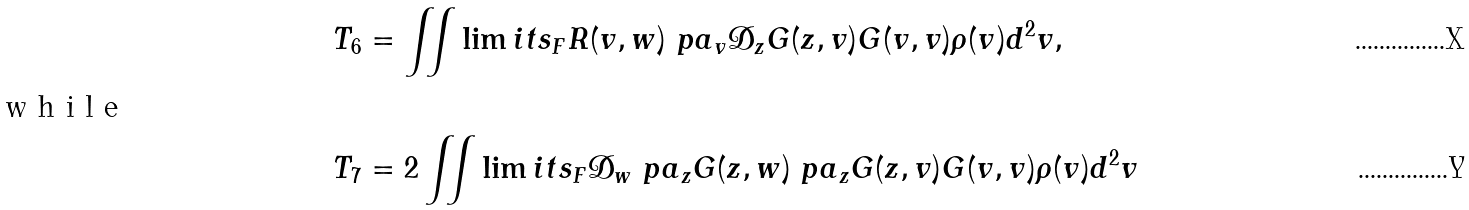<formula> <loc_0><loc_0><loc_500><loc_500>T _ { 6 } & = \iint \lim i t s _ { F } R ( v , w ) \ p a _ { v } \mathcal { D } _ { z } G ( z , v ) G ( v , v ) \rho ( v ) d ^ { 2 } v , \\ \intertext { w h i l e } T _ { 7 } & = 2 \iint \lim i t s _ { F } \mathcal { D } _ { w } \ p a _ { z } G ( z , w ) \ p a _ { z } G ( z , v ) G ( v , v ) \rho ( v ) d ^ { 2 } v</formula> 